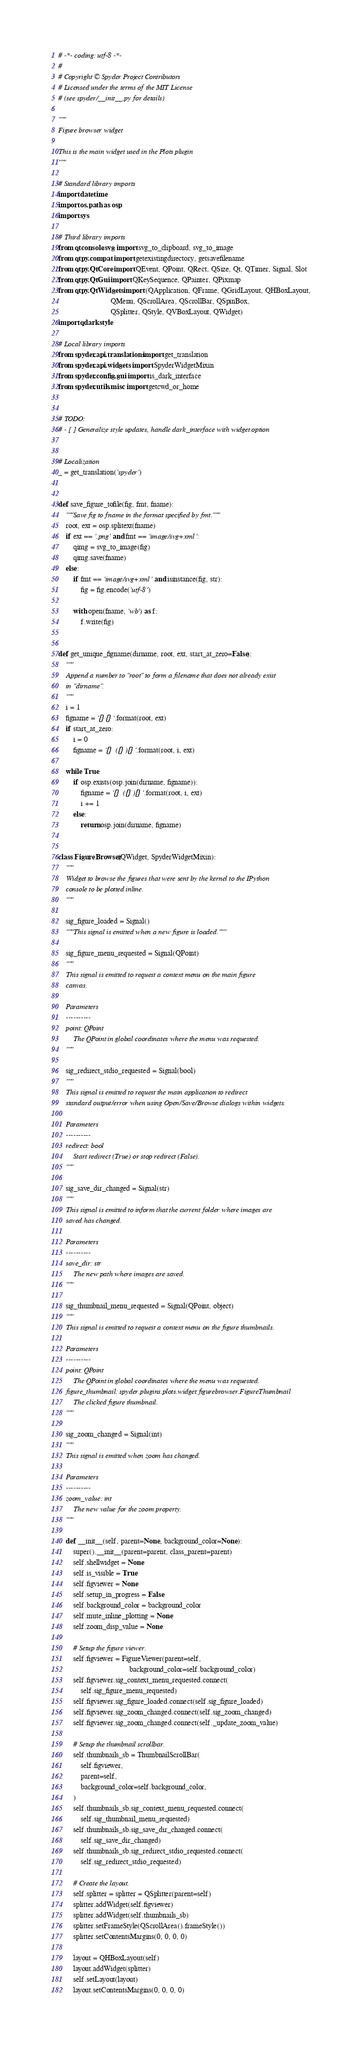Convert code to text. <code><loc_0><loc_0><loc_500><loc_500><_Python_># -*- coding: utf-8 -*-
#
# Copyright © Spyder Project Contributors
# Licensed under the terms of the MIT License
# (see spyder/__init__.py for details)

"""
Figure browser widget

This is the main widget used in the Plots plugin
"""

# Standard library imports
import datetime
import os.path as osp
import sys

# Third library imports
from qtconsole.svg import svg_to_clipboard, svg_to_image
from qtpy.compat import getexistingdirectory, getsavefilename
from qtpy.QtCore import QEvent, QPoint, QRect, QSize, Qt, QTimer, Signal, Slot
from qtpy.QtGui import QKeySequence, QPainter, QPixmap
from qtpy.QtWidgets import (QApplication, QFrame, QGridLayout, QHBoxLayout,
                            QMenu, QScrollArea, QScrollBar, QSpinBox,
                            QSplitter, QStyle, QVBoxLayout, QWidget)
import qdarkstyle

# Local library imports
from spyder.api.translations import get_translation
from spyder.api.widgets import SpyderWidgetMixin
from spyder.config.gui import is_dark_interface
from spyder.utils.misc import getcwd_or_home


# TODO:
# - [ ] Generalize style updates, handle dark_interface with widget option


# Localization
_ = get_translation('spyder')


def save_figure_tofile(fig, fmt, fname):
    """Save fig to fname in the format specified by fmt."""
    root, ext = osp.splitext(fname)
    if ext == '.png' and fmt == 'image/svg+xml':
        qimg = svg_to_image(fig)
        qimg.save(fname)
    else:
        if fmt == 'image/svg+xml' and isinstance(fig, str):
            fig = fig.encode('utf-8')

        with open(fname, 'wb') as f:
            f.write(fig)


def get_unique_figname(dirname, root, ext, start_at_zero=False):
    """
    Append a number to "root" to form a filename that does not already exist
    in "dirname".
    """
    i = 1
    figname = '{}{}'.format(root, ext)
    if start_at_zero:
        i = 0
        figname = '{} ({}){}'.format(root, i, ext)

    while True:
        if osp.exists(osp.join(dirname, figname)):
            figname = '{} ({}){}'.format(root, i, ext)
            i += 1
        else:
            return osp.join(dirname, figname)


class FigureBrowser(QWidget, SpyderWidgetMixin):
    """
    Widget to browse the figures that were sent by the kernel to the IPython
    console to be plotted inline.
    """

    sig_figure_loaded = Signal()
    """This signal is emitted when a new figure is loaded."""

    sig_figure_menu_requested = Signal(QPoint)
    """
    This signal is emitted to request a context menu on the main figure
    canvas.

    Parameters
    ----------
    point: QPoint
        The QPoint in global coordinates where the menu was requested.
    """

    sig_redirect_stdio_requested = Signal(bool)
    """
    This signal is emitted to request the main application to redirect
    standard output/error when using Open/Save/Browse dialogs within widgets.

    Parameters
    ----------
    redirect: bool
        Start redirect (True) or stop redirect (False).
    """

    sig_save_dir_changed = Signal(str)
    """
    This signal is emitted to inform that the current folder where images are
    saved has changed.

    Parameters
    ----------
    save_dir: str
        The new path where images are saved.
    """

    sig_thumbnail_menu_requested = Signal(QPoint, object)
    """
    This signal is emitted to request a context menu on the figure thumbnails.

    Parameters
    ----------
    point: QPoint
        The QPoint in global coordinates where the menu was requested.
    figure_thumbnail: spyder.plugins.plots.widget.figurebrowser.FigureThumbnail
        The clicked figure thumbnail.
    """

    sig_zoom_changed = Signal(int)
    """
    This signal is emitted when zoom has changed.

    Parameters
    ----------
    zoom_value: int
        The new value for the zoom property.
    """

    def __init__(self, parent=None, background_color=None):
        super().__init__(parent=parent, class_parent=parent)
        self.shellwidget = None
        self.is_visible = True
        self.figviewer = None
        self.setup_in_progress = False
        self.background_color = background_color
        self.mute_inline_plotting = None
        self.zoom_disp_value = None

        # Setup the figure viewer.
        self.figviewer = FigureViewer(parent=self,
                                      background_color=self.background_color)
        self.figviewer.sig_context_menu_requested.connect(
            self.sig_figure_menu_requested)
        self.figviewer.sig_figure_loaded.connect(self.sig_figure_loaded)
        self.figviewer.sig_zoom_changed.connect(self.sig_zoom_changed)
        self.figviewer.sig_zoom_changed.connect(self._update_zoom_value)

        # Setup the thumbnail scrollbar.
        self.thumbnails_sb = ThumbnailScrollBar(
            self.figviewer,
            parent=self,
            background_color=self.background_color,
        )
        self.thumbnails_sb.sig_context_menu_requested.connect(
            self.sig_thumbnail_menu_requested)
        self.thumbnails_sb.sig_save_dir_changed.connect(
            self.sig_save_dir_changed)
        self.thumbnails_sb.sig_redirect_stdio_requested.connect(
            self.sig_redirect_stdio_requested)

        # Create the layout.
        self.splitter = splitter = QSplitter(parent=self)
        splitter.addWidget(self.figviewer)
        splitter.addWidget(self.thumbnails_sb)
        splitter.setFrameStyle(QScrollArea().frameStyle())
        splitter.setContentsMargins(0, 0, 0, 0)

        layout = QHBoxLayout(self)
        layout.addWidget(splitter)
        self.setLayout(layout)
        layout.setContentsMargins(0, 0, 0, 0)</code> 